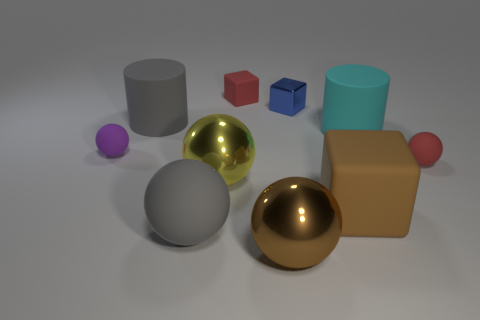Subtract all yellow balls. How many balls are left? 4 Subtract all big brown balls. How many balls are left? 4 Subtract all yellow balls. Subtract all gray cubes. How many balls are left? 4 Subtract 1 red balls. How many objects are left? 9 Subtract all cylinders. How many objects are left? 8 Subtract all red rubber balls. Subtract all tiny blue metallic balls. How many objects are left? 9 Add 7 small red things. How many small red things are left? 9 Add 5 cyan metallic cubes. How many cyan metallic cubes exist? 5 